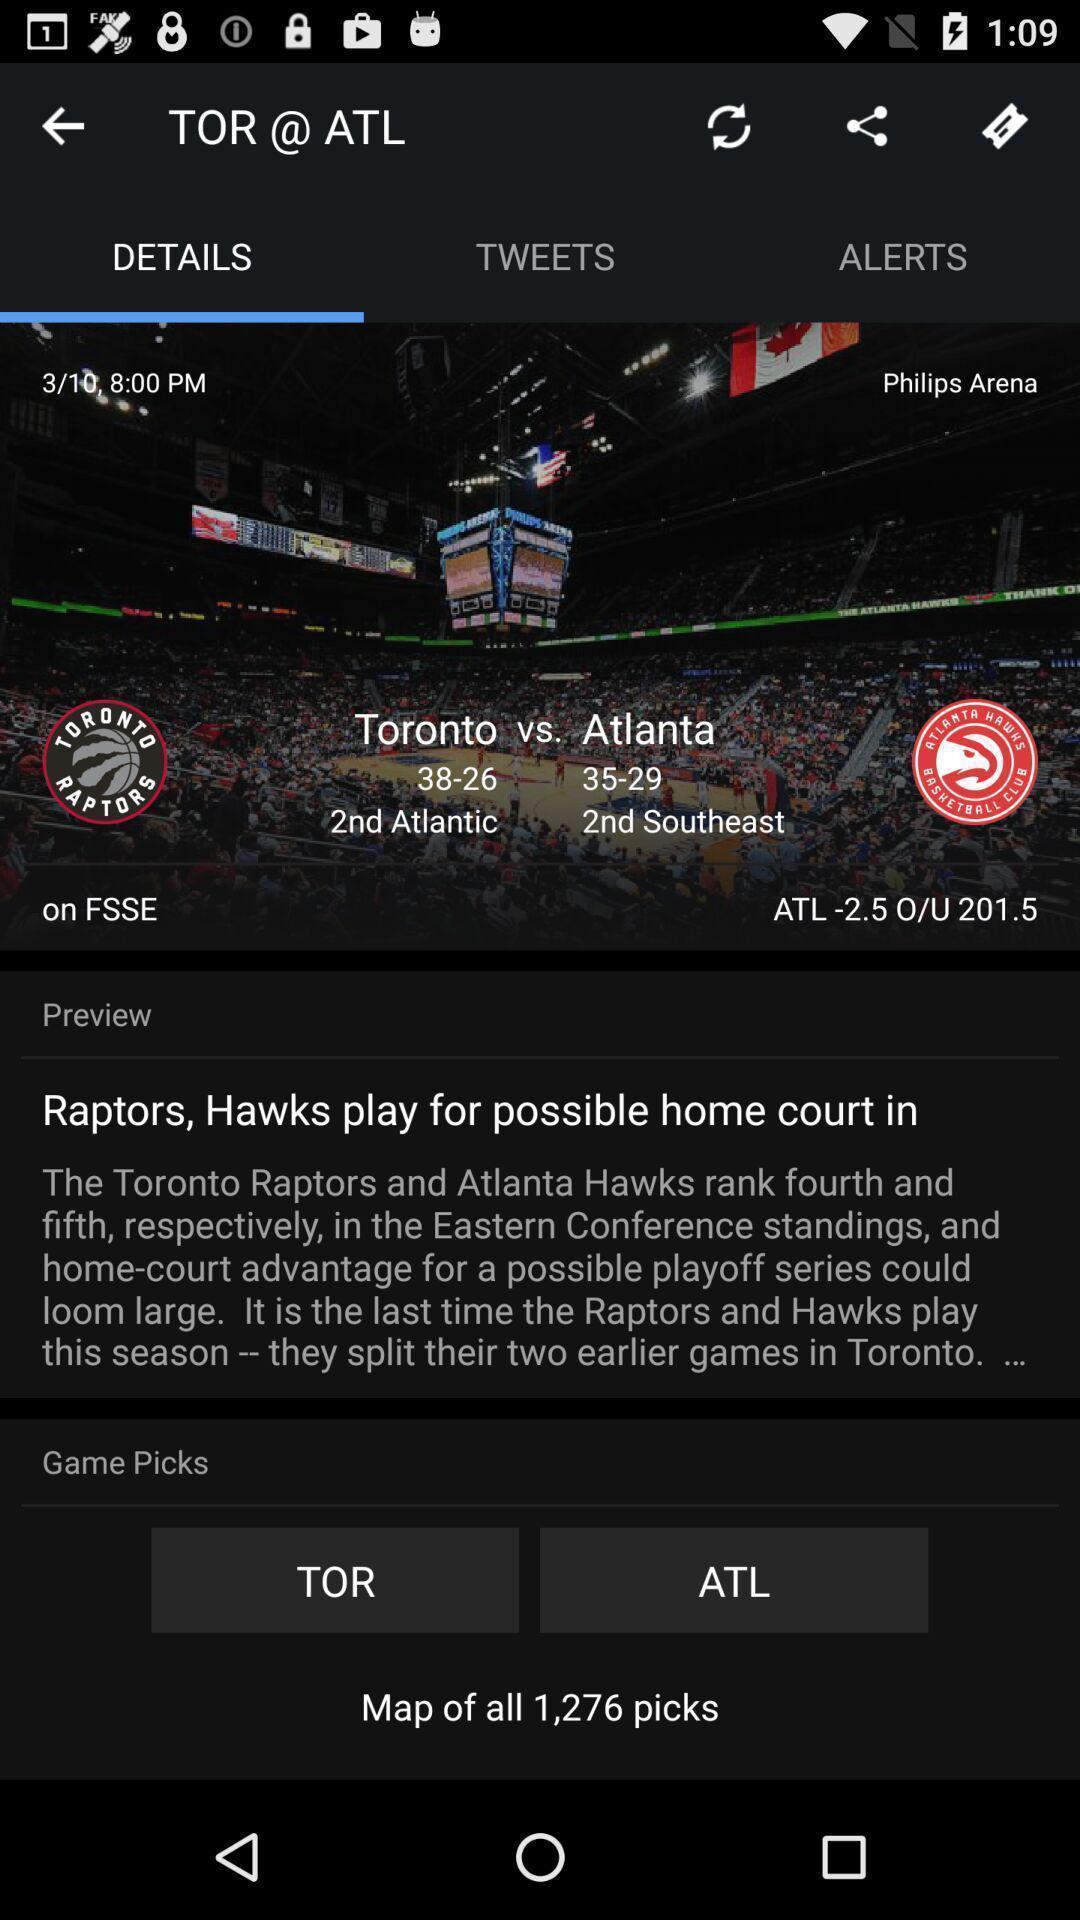Give me a narrative description of this picture. Screen showing the details of a sports game. 